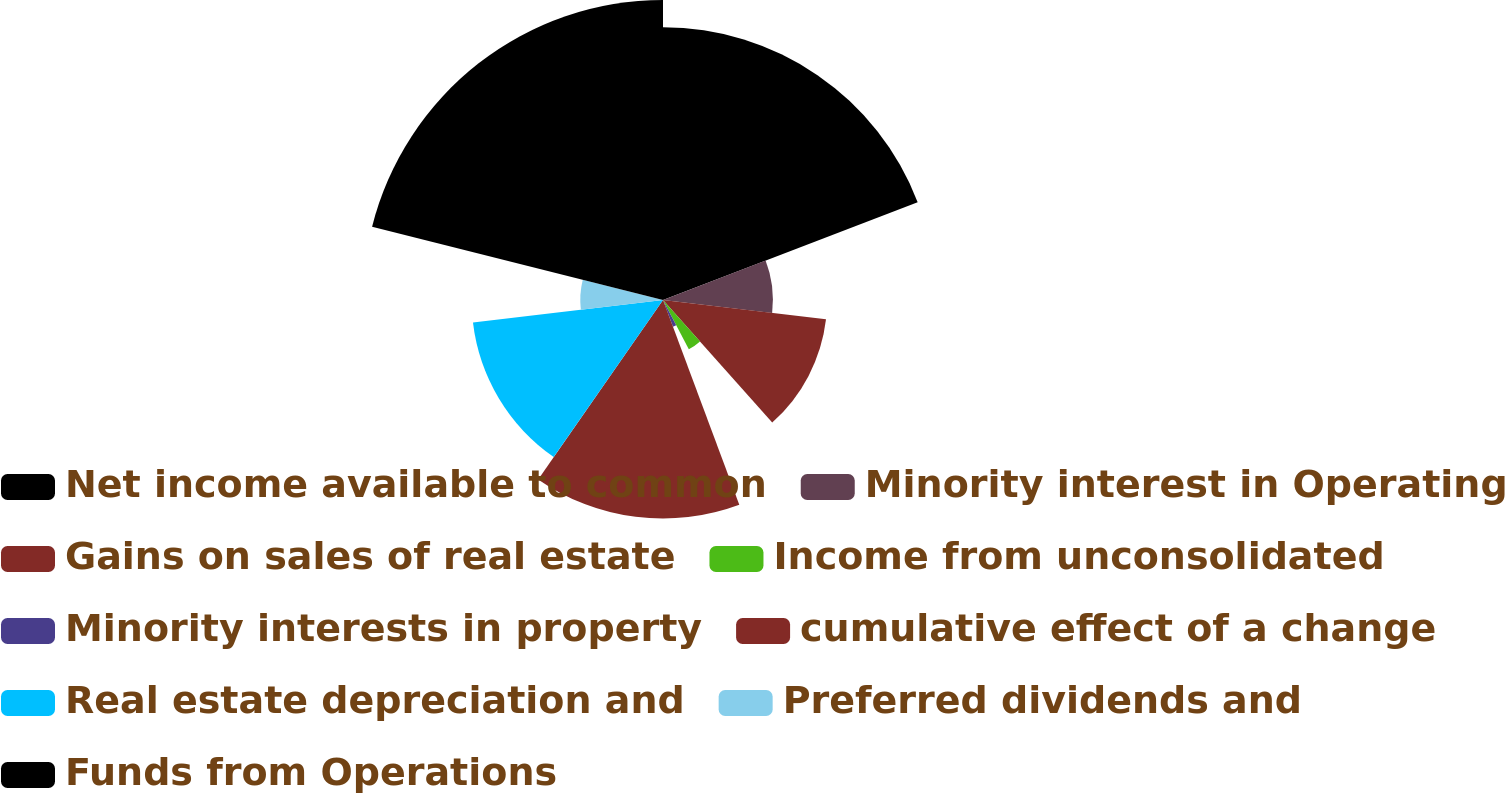Convert chart. <chart><loc_0><loc_0><loc_500><loc_500><pie_chart><fcel>Net income available to common<fcel>Minority interest in Operating<fcel>Gains on sales of real estate<fcel>Income from unconsolidated<fcel>Minority interests in property<fcel>cumulative effect of a change<fcel>Real estate depreciation and<fcel>Preferred dividends and<fcel>Funds from Operations<nl><fcel>19.16%<fcel>7.72%<fcel>11.53%<fcel>3.91%<fcel>2.0%<fcel>15.35%<fcel>13.44%<fcel>5.81%<fcel>21.07%<nl></chart> 